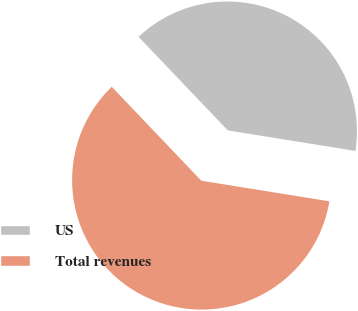Convert chart. <chart><loc_0><loc_0><loc_500><loc_500><pie_chart><fcel>US<fcel>Total revenues<nl><fcel>39.66%<fcel>60.34%<nl></chart> 